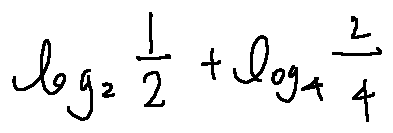Convert formula to latex. <formula><loc_0><loc_0><loc_500><loc_500>\log _ { 2 } \frac { 1 } { 2 } + \log _ { 4 } \frac { 2 } { 4 }</formula> 